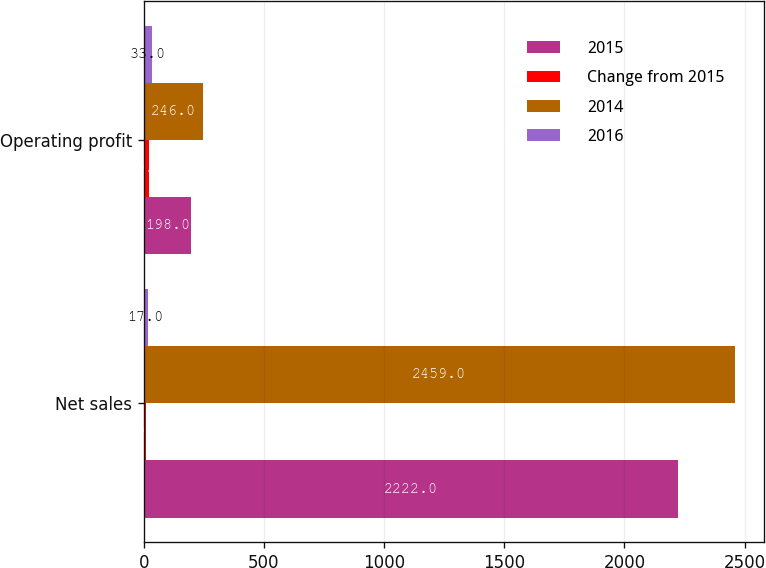Convert chart to OTSL. <chart><loc_0><loc_0><loc_500><loc_500><stacked_bar_chart><ecel><fcel>Net sales<fcel>Operating profit<nl><fcel>2015<fcel>2222<fcel>198<nl><fcel>Change from 2015<fcel>10<fcel>20<nl><fcel>2014<fcel>2459<fcel>246<nl><fcel>2016<fcel>17<fcel>33<nl></chart> 